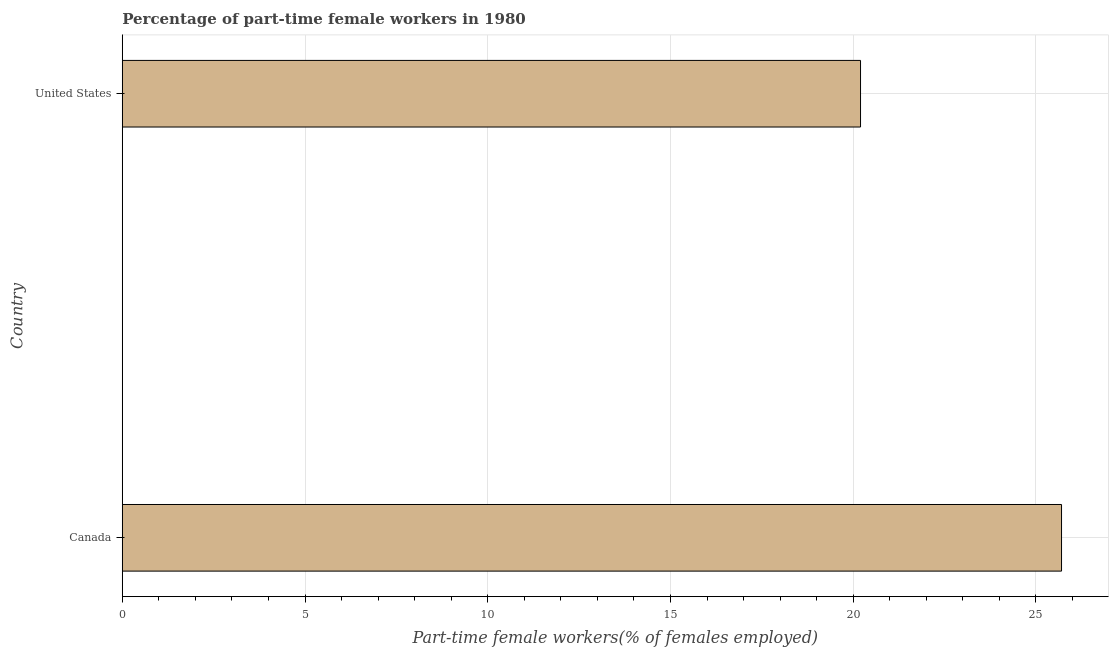Does the graph contain any zero values?
Make the answer very short. No. What is the title of the graph?
Make the answer very short. Percentage of part-time female workers in 1980. What is the label or title of the X-axis?
Make the answer very short. Part-time female workers(% of females employed). What is the label or title of the Y-axis?
Your answer should be very brief. Country. What is the percentage of part-time female workers in United States?
Your response must be concise. 20.2. Across all countries, what is the maximum percentage of part-time female workers?
Offer a very short reply. 25.7. Across all countries, what is the minimum percentage of part-time female workers?
Offer a terse response. 20.2. In which country was the percentage of part-time female workers maximum?
Provide a short and direct response. Canada. What is the sum of the percentage of part-time female workers?
Provide a succinct answer. 45.9. What is the average percentage of part-time female workers per country?
Ensure brevity in your answer.  22.95. What is the median percentage of part-time female workers?
Keep it short and to the point. 22.95. In how many countries, is the percentage of part-time female workers greater than 10 %?
Offer a very short reply. 2. What is the ratio of the percentage of part-time female workers in Canada to that in United States?
Your response must be concise. 1.27. In how many countries, is the percentage of part-time female workers greater than the average percentage of part-time female workers taken over all countries?
Your answer should be compact. 1. How many countries are there in the graph?
Your response must be concise. 2. Are the values on the major ticks of X-axis written in scientific E-notation?
Your response must be concise. No. What is the Part-time female workers(% of females employed) in Canada?
Provide a succinct answer. 25.7. What is the Part-time female workers(% of females employed) in United States?
Provide a succinct answer. 20.2. What is the difference between the Part-time female workers(% of females employed) in Canada and United States?
Offer a terse response. 5.5. What is the ratio of the Part-time female workers(% of females employed) in Canada to that in United States?
Offer a very short reply. 1.27. 